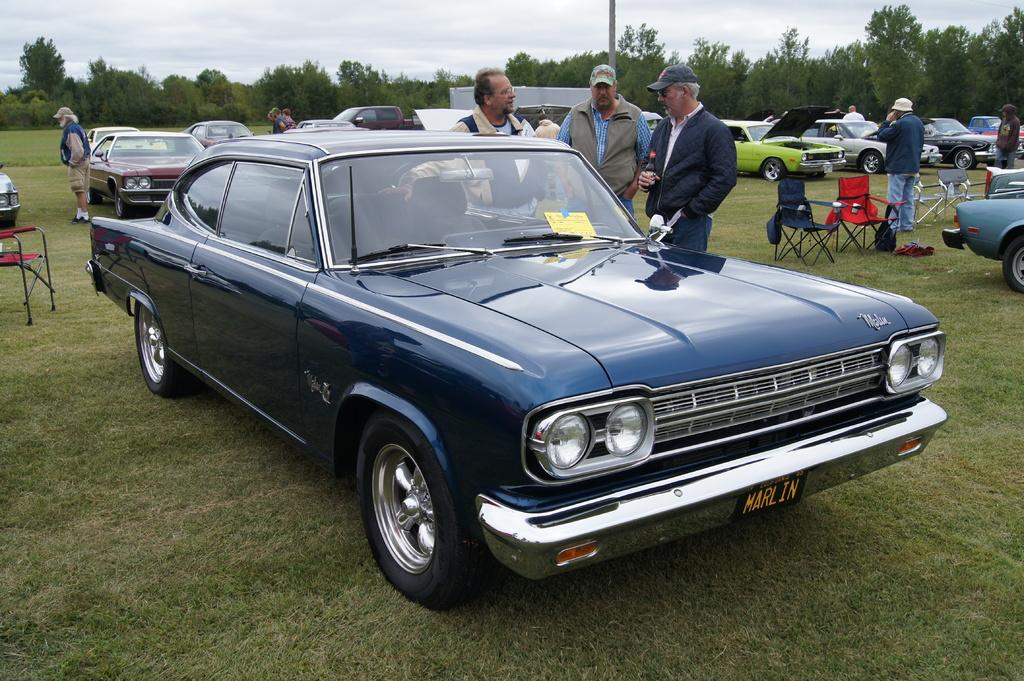<image>
Write a terse but informative summary of the picture. The blue car in the picture is from the California 